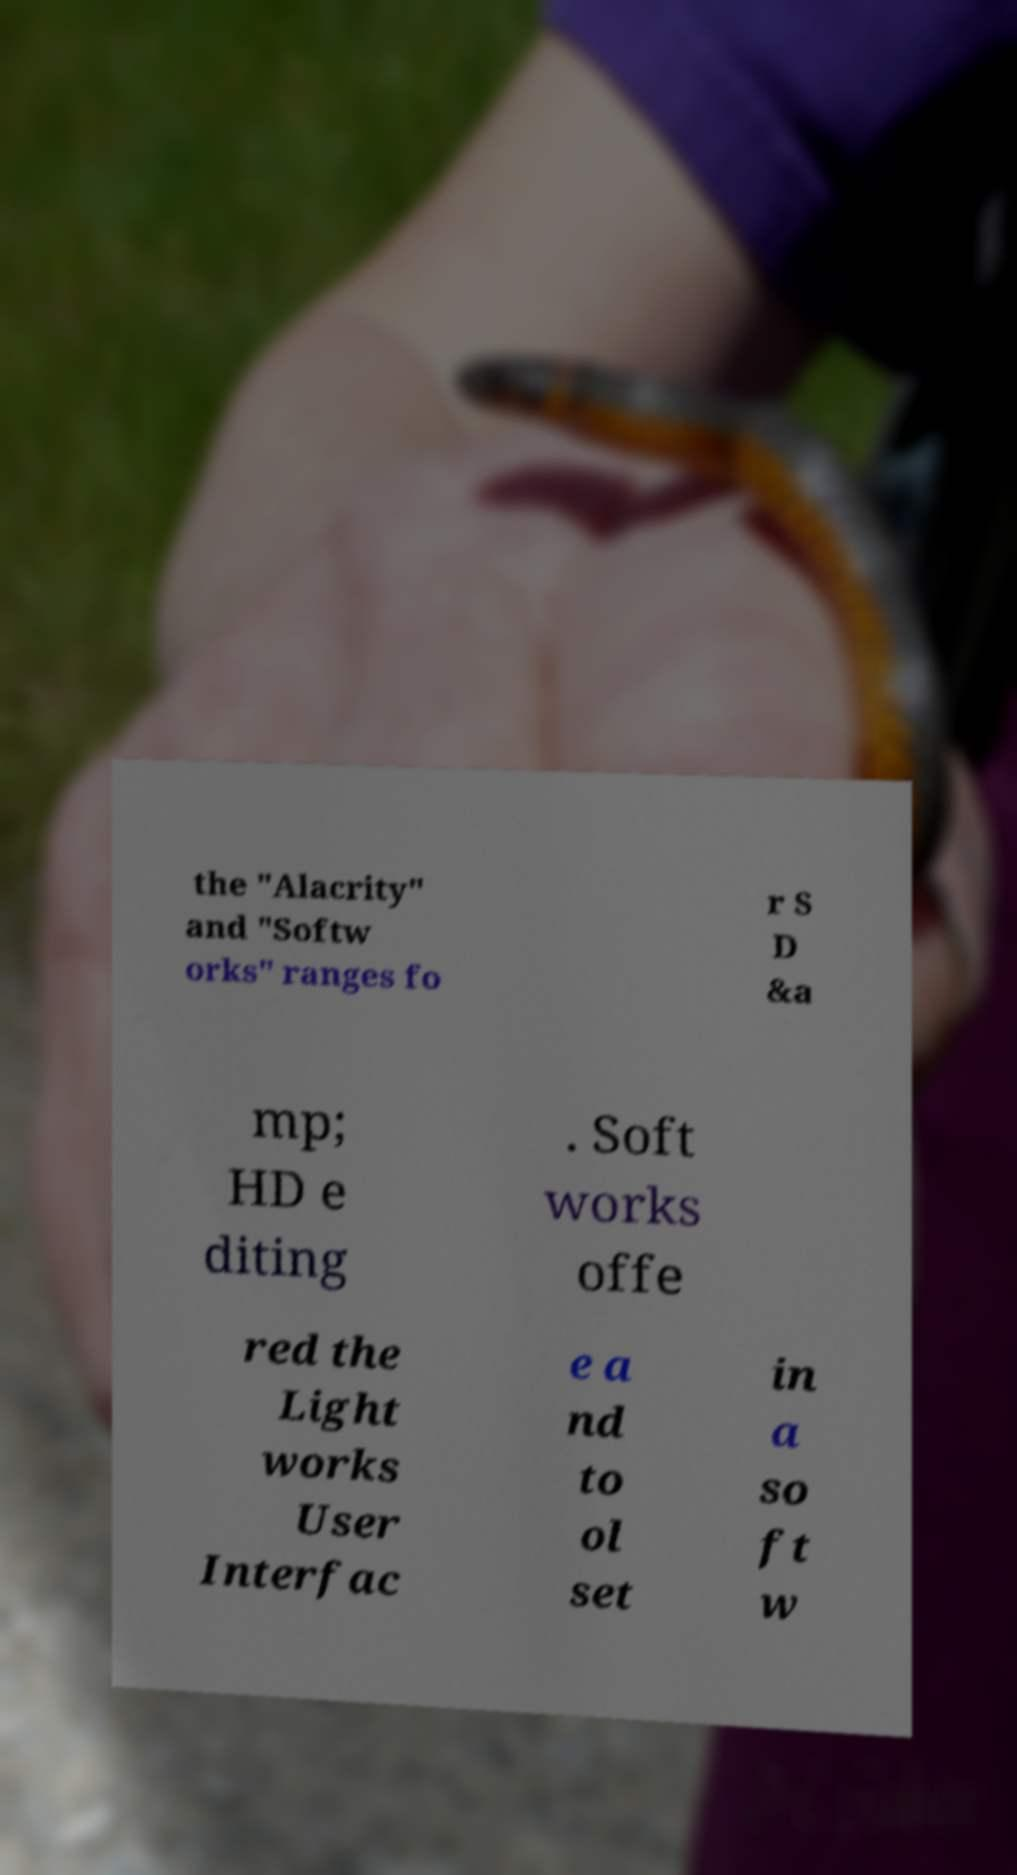Can you accurately transcribe the text from the provided image for me? the "Alacrity" and "Softw orks" ranges fo r S D &a mp; HD e diting . Soft works offe red the Light works User Interfac e a nd to ol set in a so ft w 